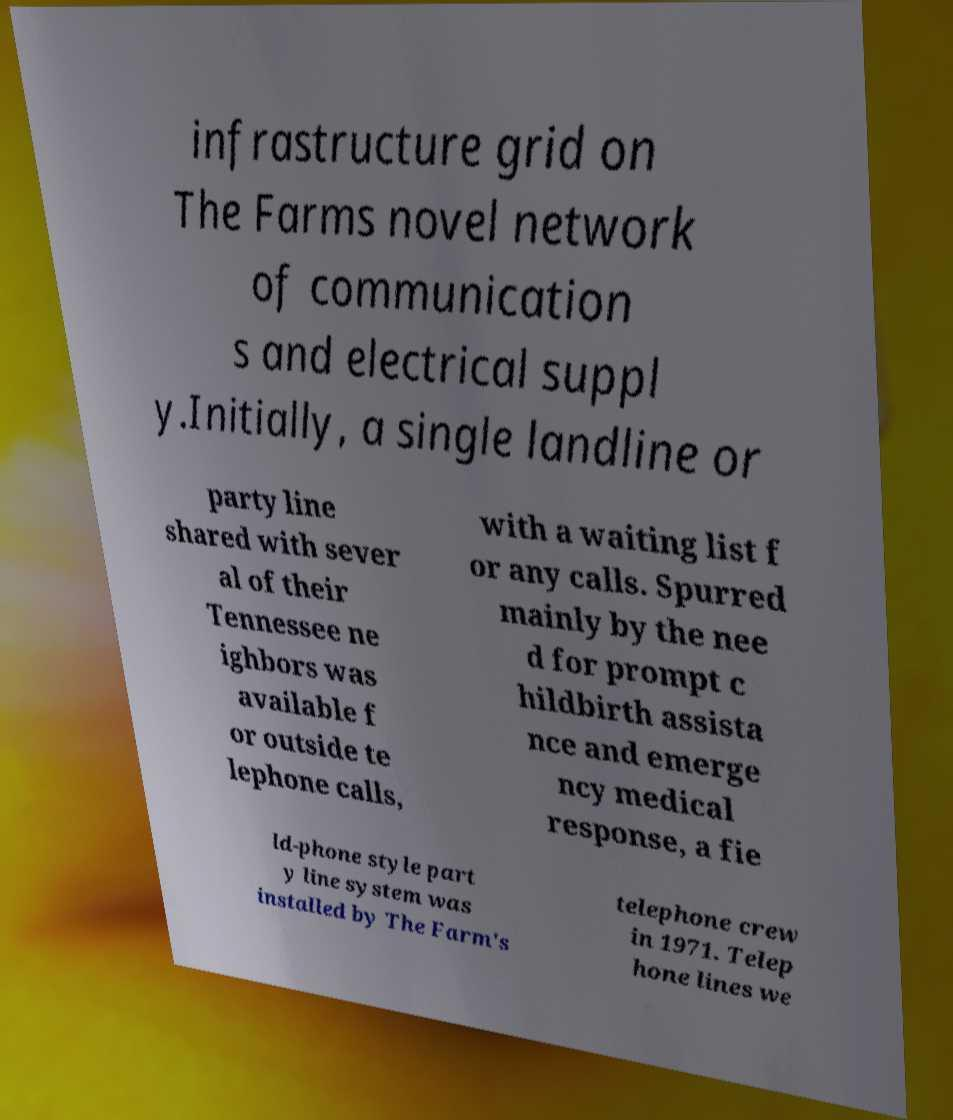Could you extract and type out the text from this image? infrastructure grid on The Farms novel network of communication s and electrical suppl y.Initially, a single landline or party line shared with sever al of their Tennessee ne ighbors was available f or outside te lephone calls, with a waiting list f or any calls. Spurred mainly by the nee d for prompt c hildbirth assista nce and emerge ncy medical response, a fie ld-phone style part y line system was installed by The Farm's telephone crew in 1971. Telep hone lines we 